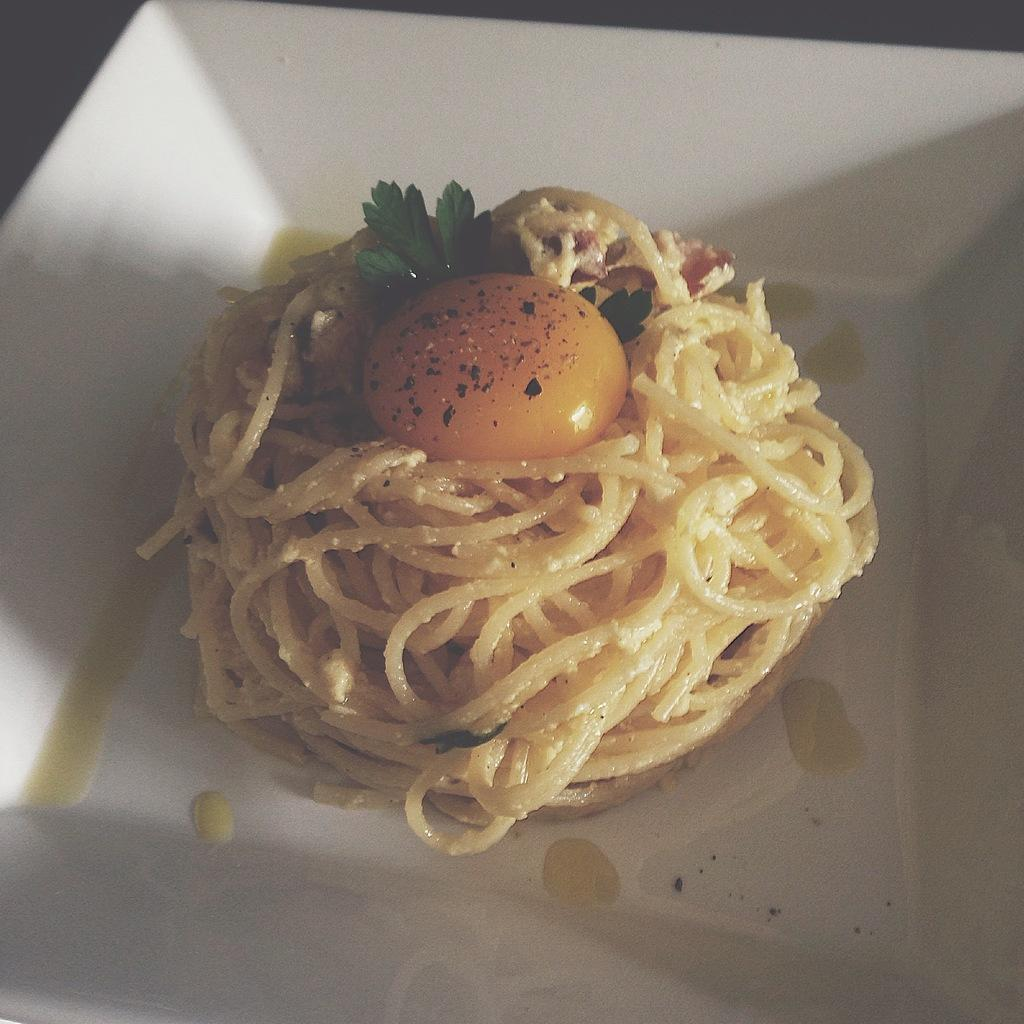What is present in the image that can hold food? There is a bowl in the image that can hold food. What type of food is in the bowl? The bowl contains a food item that is garnished with leaves. Can you describe the appearance of the food item? The food item has an egg yolk on top of it. What type of government is depicted in the image? There is no depiction of a government in the image; it features a bowl with a food item. How many goldfish are swimming in the bowl in the image? There are no goldfish present in the image; it features a bowl with a food item. 